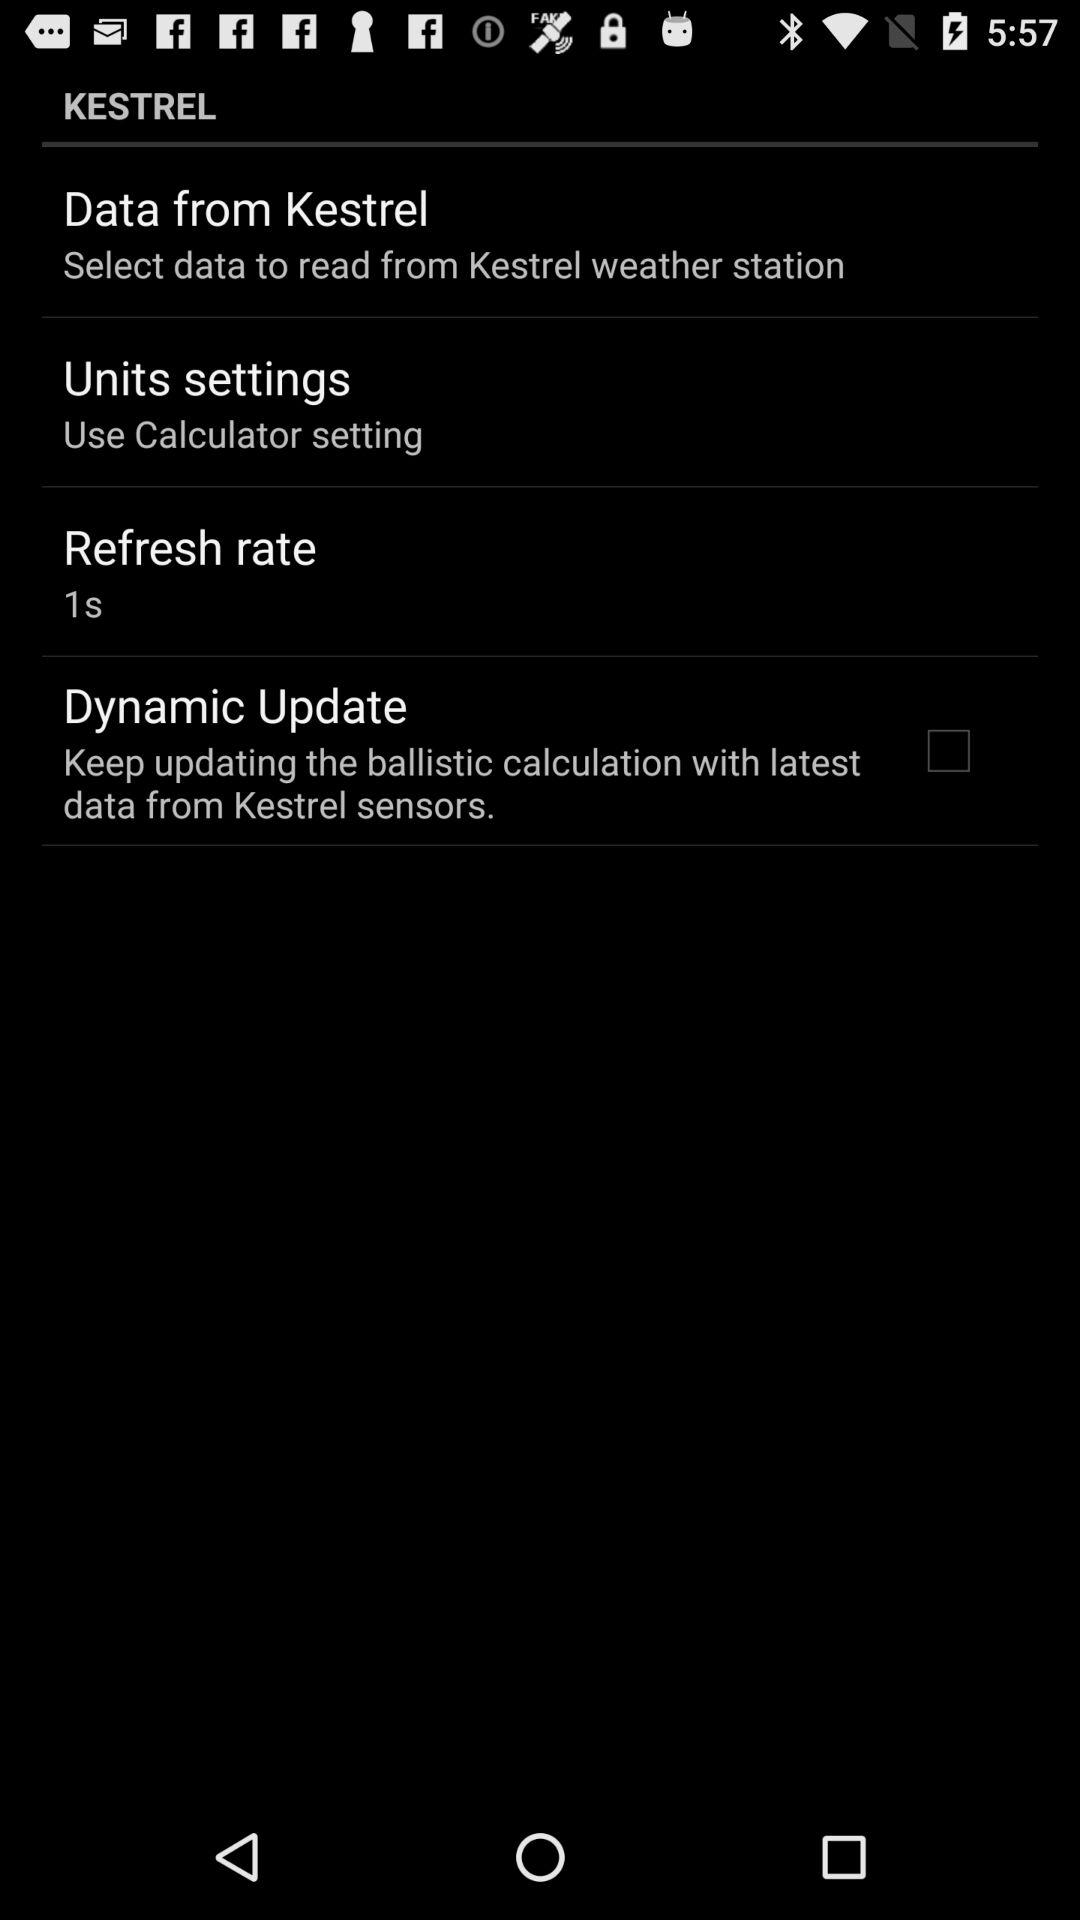What is the status of "Dynamic Update"? The status of "Dynamic Update" is "off". 